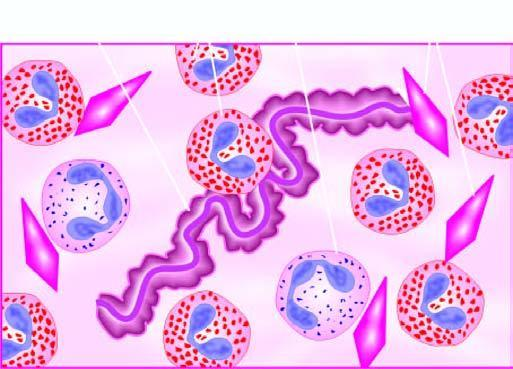what plugs in patients with bronchial asthma?
Answer the question using a single word or phrase. Diagrammatic appearance of curschmann's spiral and charcot-leyden crystals found in mucus 